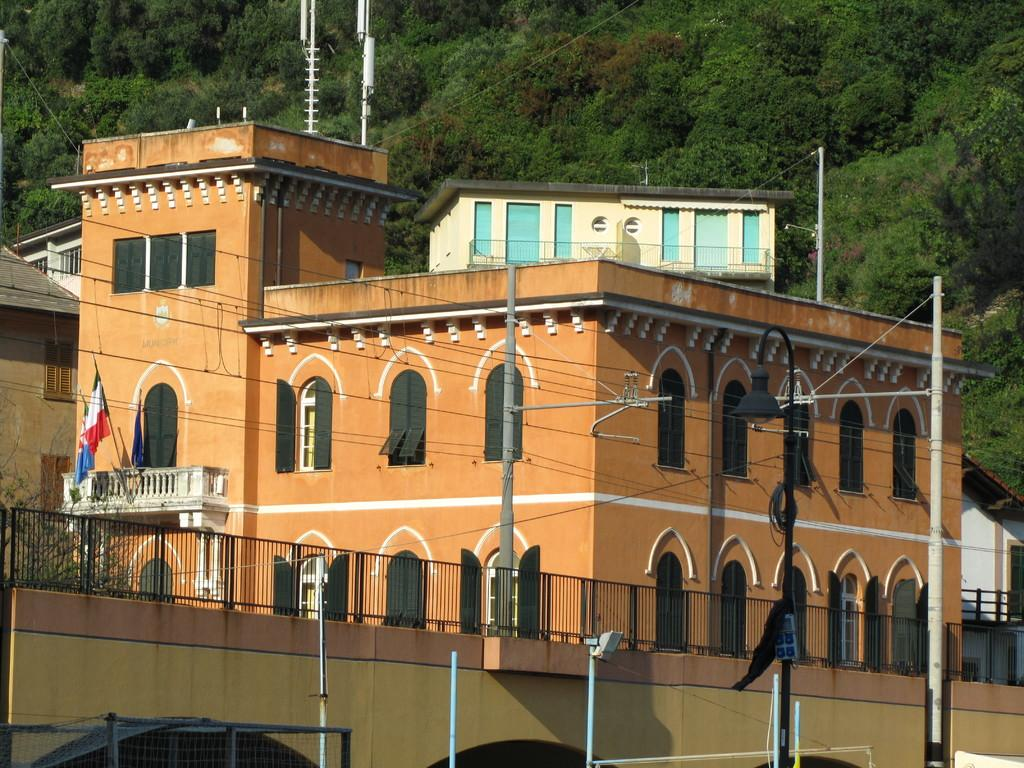What type of structure is visible in the image? There is a building in the image. What is located near the building? There is a fence in the image. What other objects can be seen in the image? There are poles and lights visible in the image. What can be seen in the background of the image? There are trees in the background of the image. What type of cushion is used to reduce friction on the poles in the image? There is no cushion present in the image, nor is there any mention of friction or its reduction. 